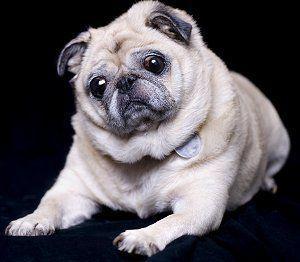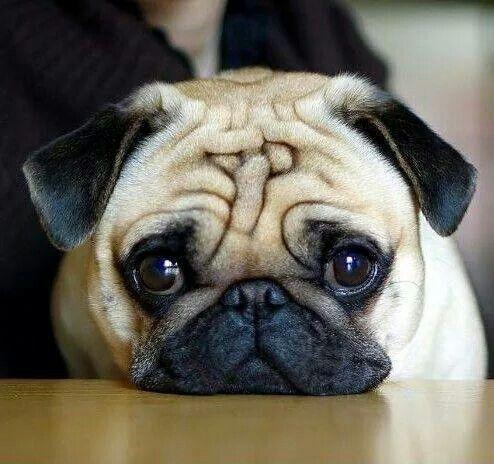The first image is the image on the left, the second image is the image on the right. For the images shown, is this caption "The pug reclining in the right image has paws extended in front." true? Answer yes or no. No. 